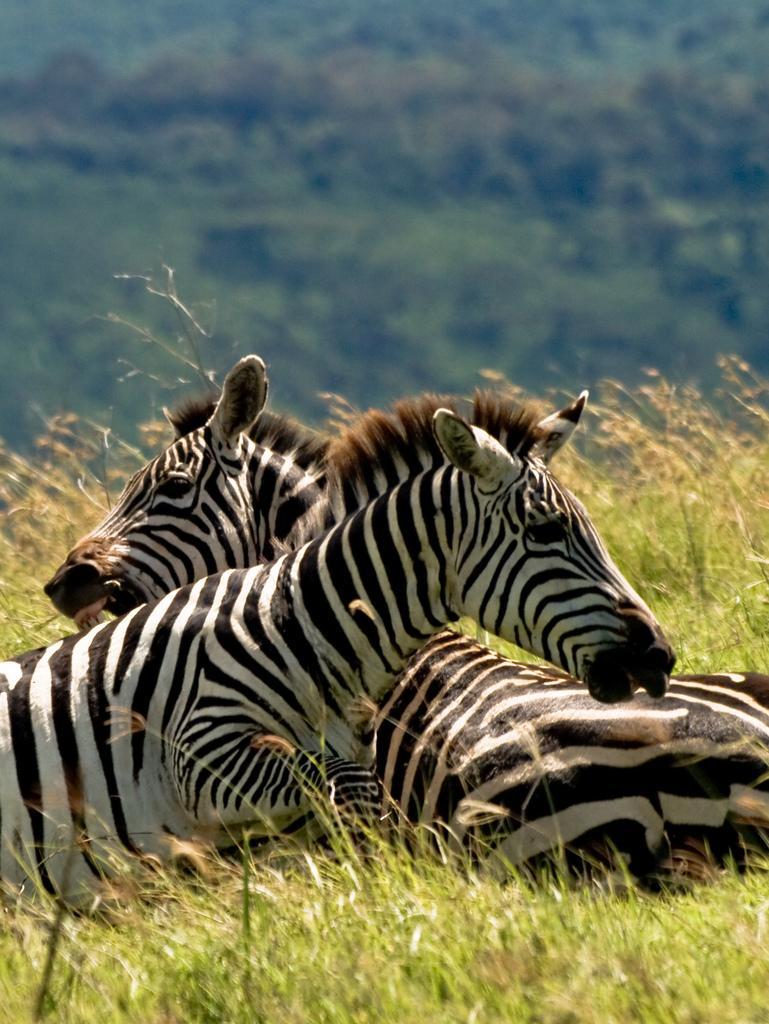Please provide a concise description of this image. In this image we can see two animals. We can see the grass. In the background, we can see a group of trees. 